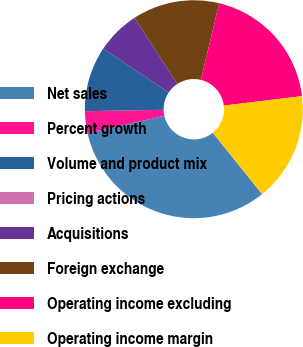Convert chart. <chart><loc_0><loc_0><loc_500><loc_500><pie_chart><fcel>Net sales<fcel>Percent growth<fcel>Volume and product mix<fcel>Pricing actions<fcel>Acquisitions<fcel>Foreign exchange<fcel>Operating income excluding<fcel>Operating income margin<nl><fcel>32.26%<fcel>3.23%<fcel>9.68%<fcel>0.0%<fcel>6.45%<fcel>12.9%<fcel>19.35%<fcel>16.13%<nl></chart> 